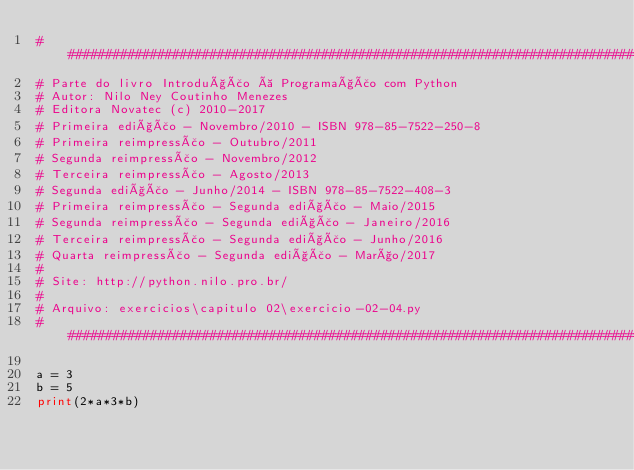Convert code to text. <code><loc_0><loc_0><loc_500><loc_500><_Python_>##############################################################################
# Parte do livro Introdução à Programação com Python
# Autor: Nilo Ney Coutinho Menezes
# Editora Novatec (c) 2010-2017
# Primeira edição - Novembro/2010 - ISBN 978-85-7522-250-8
# Primeira reimpressão - Outubro/2011
# Segunda reimpressão - Novembro/2012
# Terceira reimpressão - Agosto/2013
# Segunda edição - Junho/2014 - ISBN 978-85-7522-408-3
# Primeira reimpressão - Segunda edição - Maio/2015
# Segunda reimpressão - Segunda edição - Janeiro/2016
# Terceira reimpressão - Segunda edição - Junho/2016
# Quarta reimpressão - Segunda edição - Março/2017
#
# Site: http://python.nilo.pro.br/
#
# Arquivo: exercicios\capitulo 02\exercicio-02-04.py
##############################################################################

a = 3
b = 5
print(2*a*3*b)

</code> 